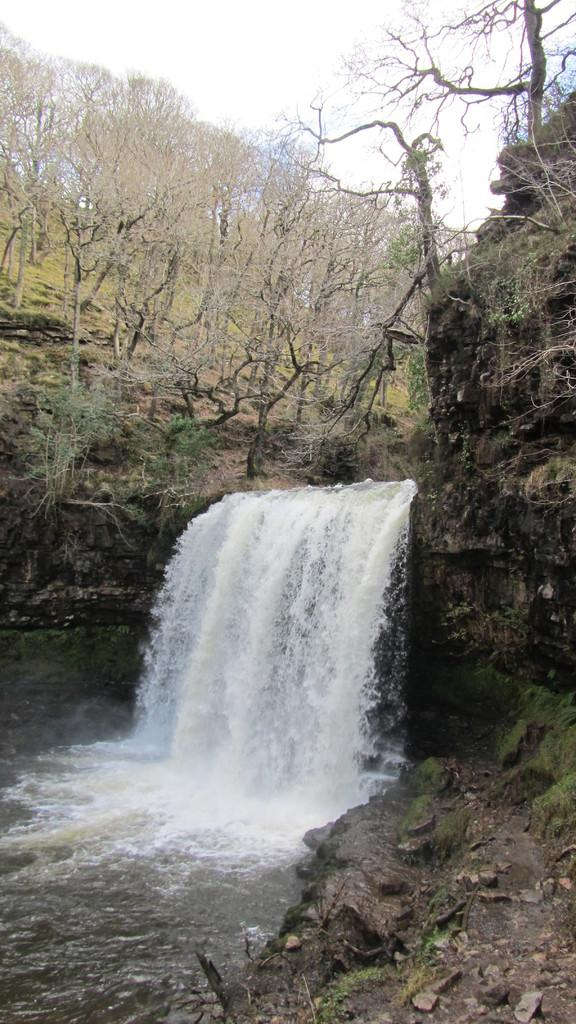What natural feature is the main subject of the image? There is a waterfall in the image. What type of vegetation can be seen in the background of the image? There are trees in the background of the image. What else is visible in the background of the image? The sky is visible in the background of the image. What type of apparatus is used to measure the wind speed in the image? There is no apparatus present in the image to measure wind speed. Can you see any bananas hanging from the trees in the image? There are no bananas visible in the image; only trees are present. 